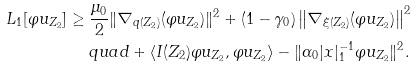<formula> <loc_0><loc_0><loc_500><loc_500>L _ { 1 } [ \varphi u _ { Z _ { 2 } } ] & \geq \frac { \mu _ { 0 } } { 2 } \| \nabla _ { q ( Z _ { 2 } ) } ( \varphi u _ { Z _ { 2 } } ) \| ^ { 2 } + ( 1 - \gamma _ { 0 } ) \left \| \nabla _ { \xi ( Z _ { 2 } ) } ( \varphi u _ { Z _ { 2 } } ) \right \| ^ { 2 } \\ & \ \quad q u a d + \langle I ( Z _ { 2 } ) \varphi u _ { Z _ { 2 } } , \varphi u _ { Z _ { 2 } } \rangle - \| \alpha _ { 0 } | x | _ { 1 } ^ { - 1 } \varphi u _ { Z _ { 2 } } \| ^ { 2 } .</formula> 